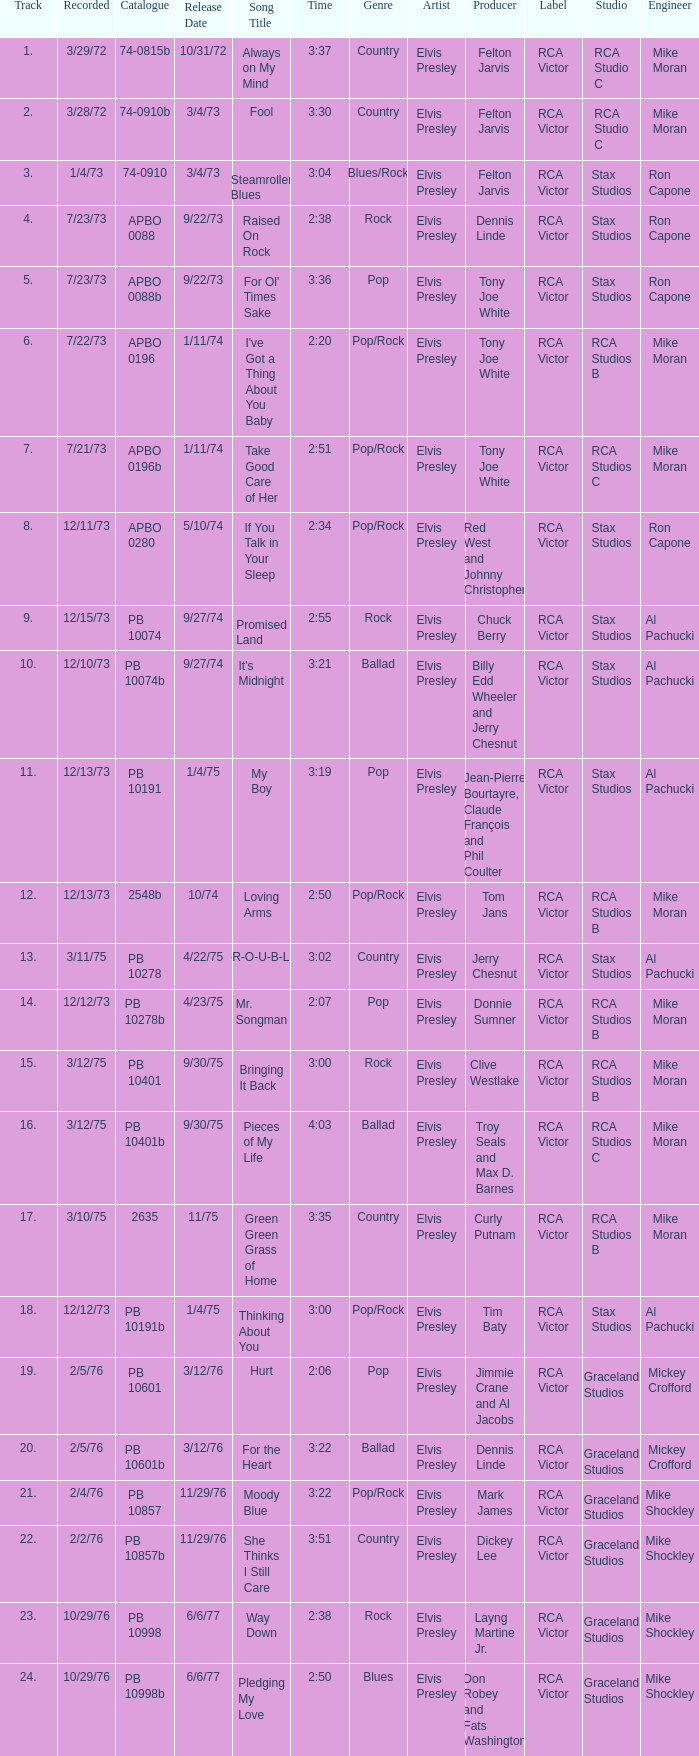Name the catalogue that has tracks less than 13 and the release date of 10/31/72 74-0815b. 